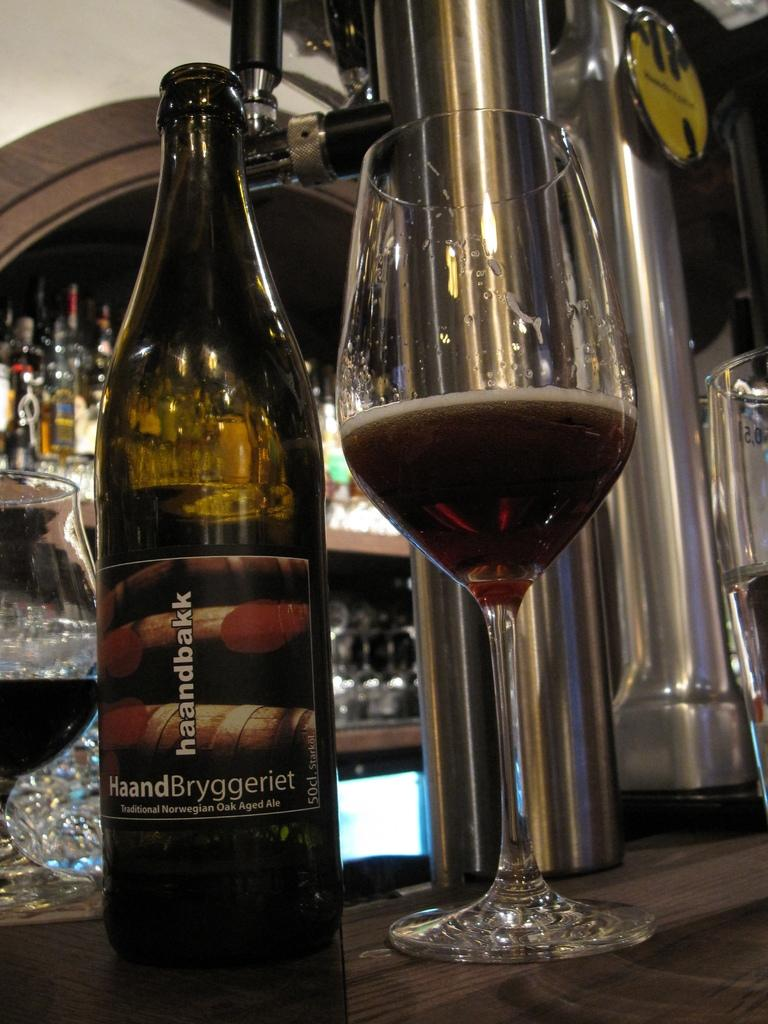What is located in the center of the image? There is a bottle and a glass in the center of a drink in the center of the image. What is the glass filled with? The glass is filled with a drink. Are there any other bottles or glasses visible in the image? Yes, there are bottles and glasses in the background of the image. How does the tin affect the taste of the drink in the glass? There is no tin present in the image, so it cannot affect the taste of the drink in the glass. 